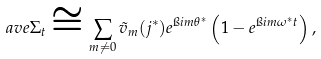Convert formula to latex. <formula><loc_0><loc_0><loc_500><loc_500>\ a v e { \Sigma _ { t } } \cong \sum _ { m \neq 0 } \tilde { v } _ { m } ( j ^ { * } ) e ^ { \i i m \theta ^ { * } } \left ( 1 - e ^ { \i i m \omega ^ { * } t } \right ) ,</formula> 